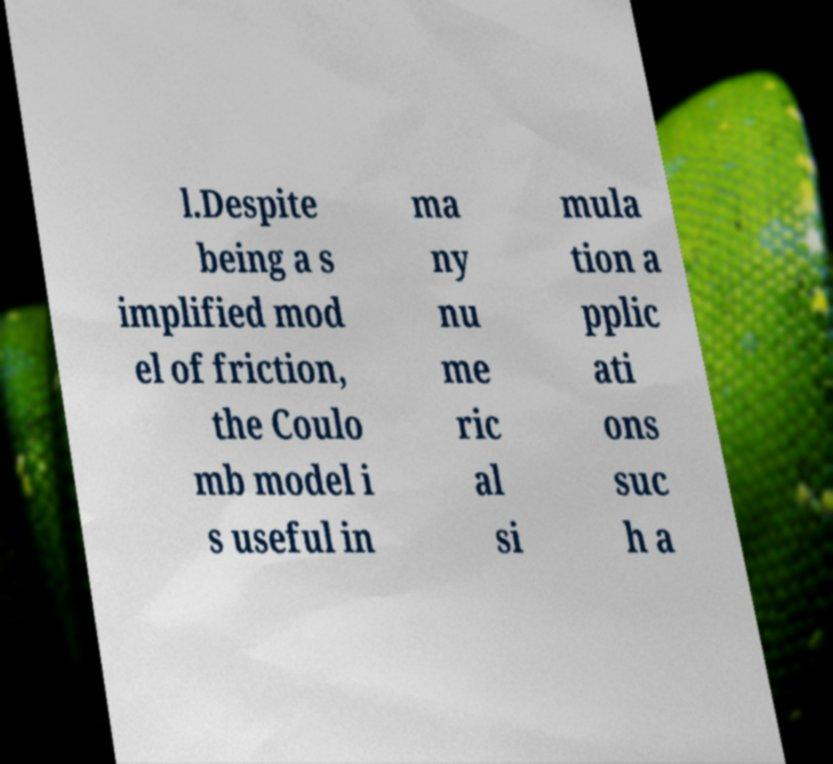Can you read and provide the text displayed in the image?This photo seems to have some interesting text. Can you extract and type it out for me? l.Despite being a s implified mod el of friction, the Coulo mb model i s useful in ma ny nu me ric al si mula tion a pplic ati ons suc h a 